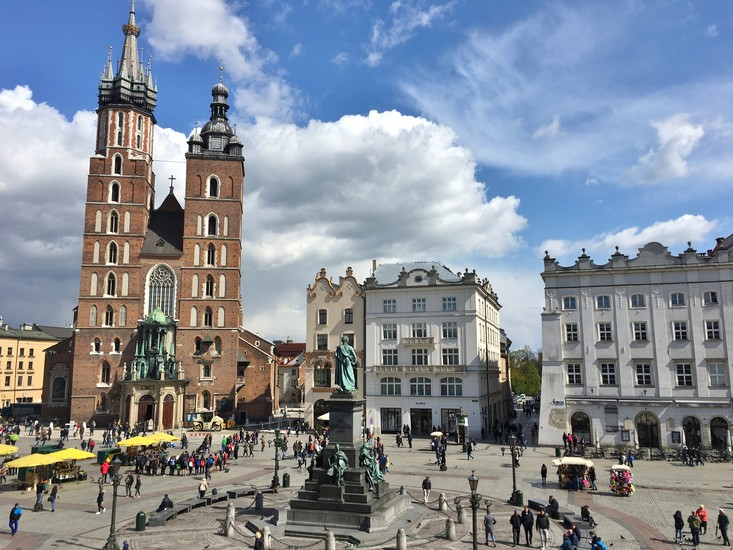How has the architecture of the buildings seen in this image evolved over time? The buildings surrounding Krakow’s Main Market Square reflect a rich tapestry of architectural evolution, influenced by various historical periods. Initially, the structures were predominantly Romanesque, characterized by thick walls and small windows. As the city flourished, Gothic architecture brought taller, more intricate facades and expansive windows, evident in the construction of St. Mary's Basilica.

The Renaissance period introduced elegant mansions with decorative elements like arcades and ornate stonework. During the Baroque era, buildings were further embellished with sculptural details, grand staircases, and vibrant frescoes. The 19th and 20th centuries saw neoclassical influences, focusing on symmetry and simplicity, while modern restorations strive to preserve these historical styles, maintaining their cultural significance while incorporating contemporary functionality.

This blend of architectural styles creates the unique aesthetic charm of the square, reflecting Krakow's dynamic history and cultural heritage. 